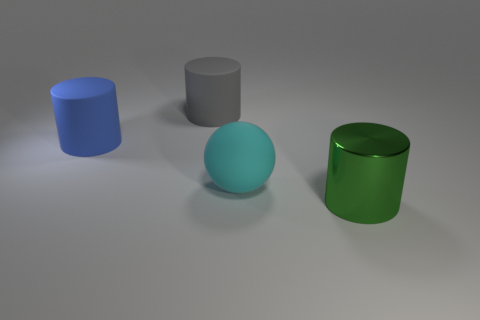Add 3 tiny purple metallic balls. How many objects exist? 7 Subtract all balls. How many objects are left? 3 Subtract all big things. Subtract all gray metal cubes. How many objects are left? 0 Add 2 blue cylinders. How many blue cylinders are left? 3 Add 3 brown cubes. How many brown cubes exist? 3 Subtract 0 red cylinders. How many objects are left? 4 